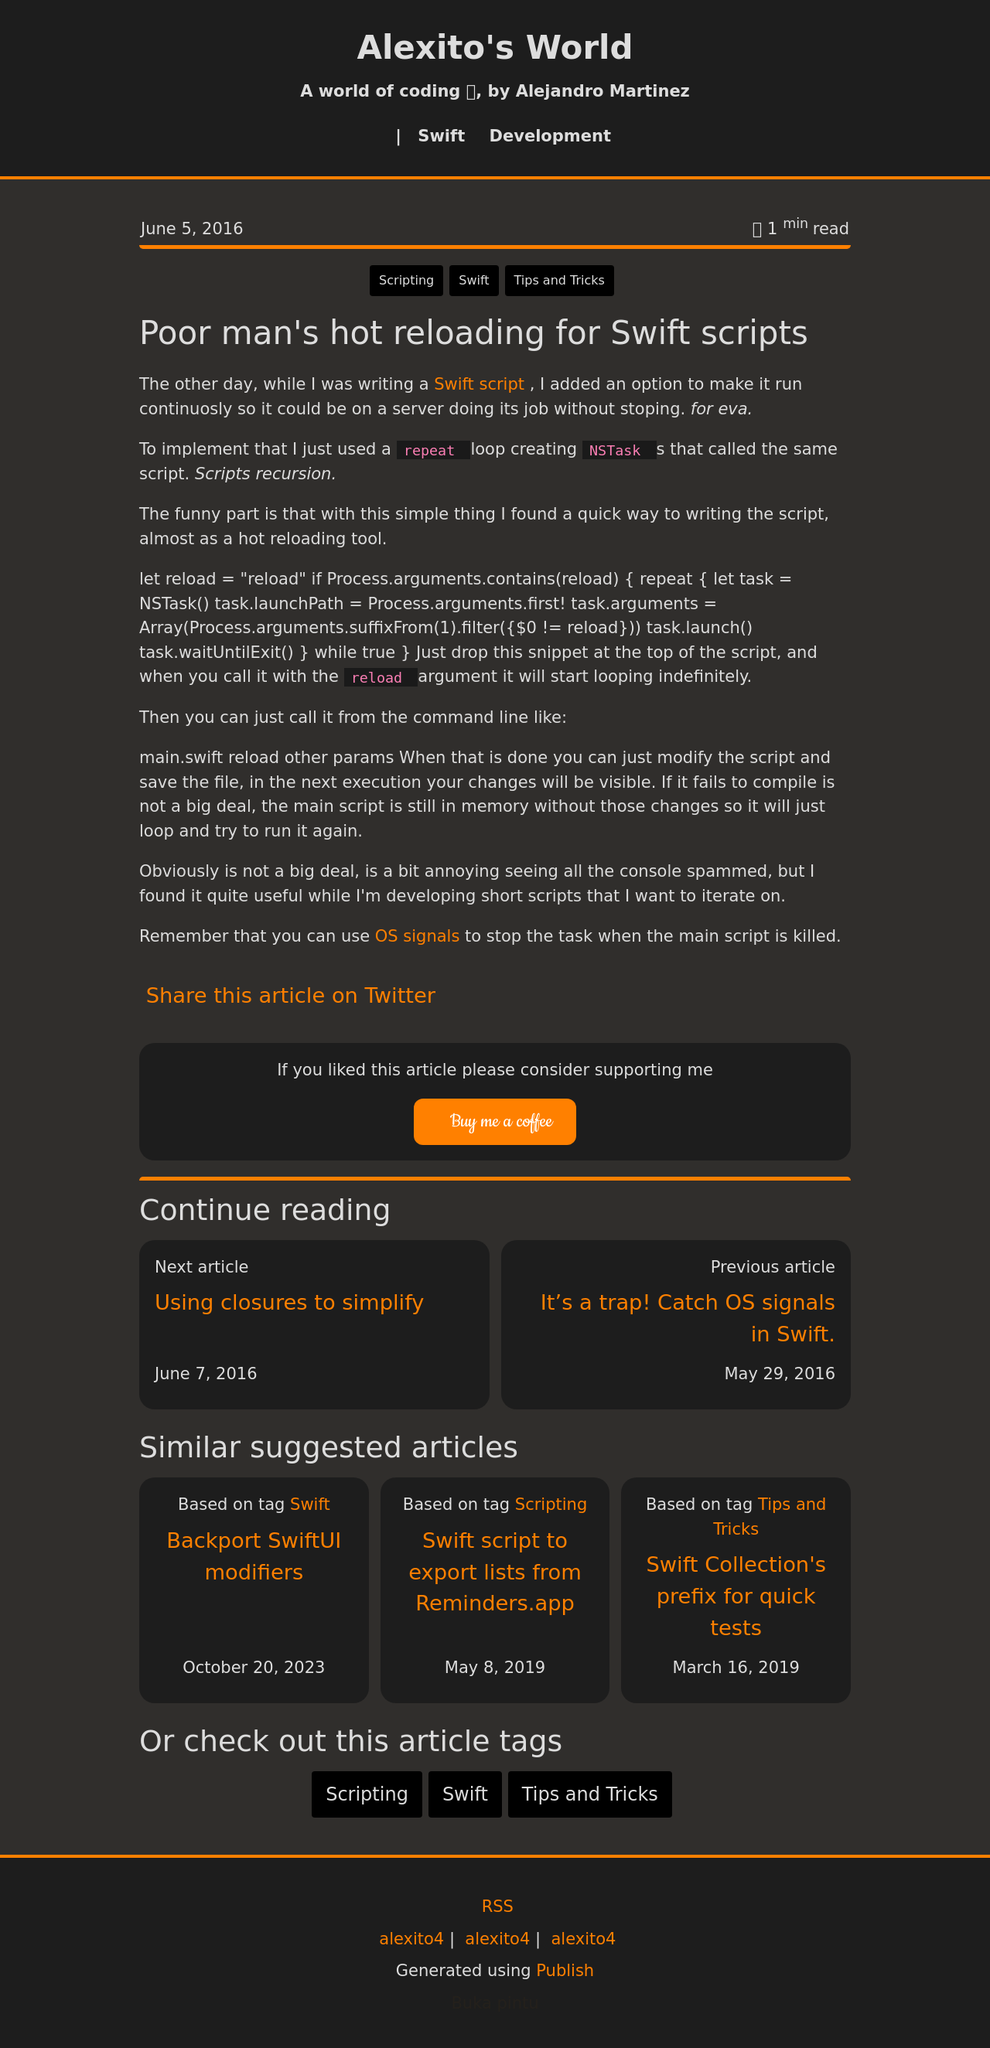How does the 'Buy me a coffee' feature integrate into the user experience on this site? The 'Buy me a coffee' feature is effectively integrated at the bottom of the article, making it a subtle yet actionable request. It's strategically placed so as not to distract from the article content but still catches the eye as the user finishes reading. This placement could potentially increase engagement by appealing to users who found value in the content and wish to support the creator in a straightforward and personal way. Is this placement standard practice for donation buttons in blogs or is it unique in some way? This placement isn't unique but is considered a best practice in blog design. It's effective because it ties the call to action directly to the user's sentiment upon consuming the content. Positioned unobtrusively yet in a spot likely to be seen by engaged readers, it balances visibility without overwhelming the main content, which can be crucial for conversion rates in donation-based monetization strategies. 